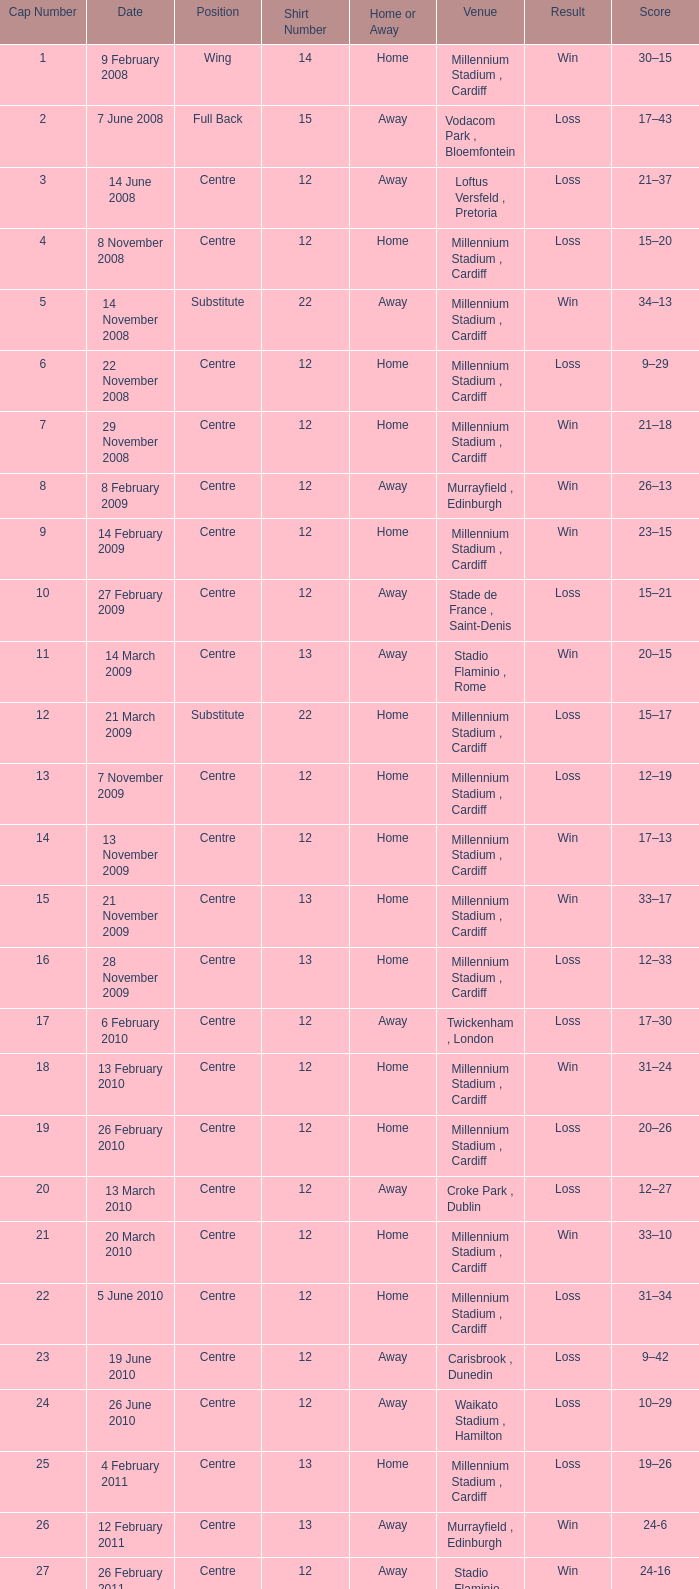What's the largest shirt number when the cap number is 5? 22.0. 